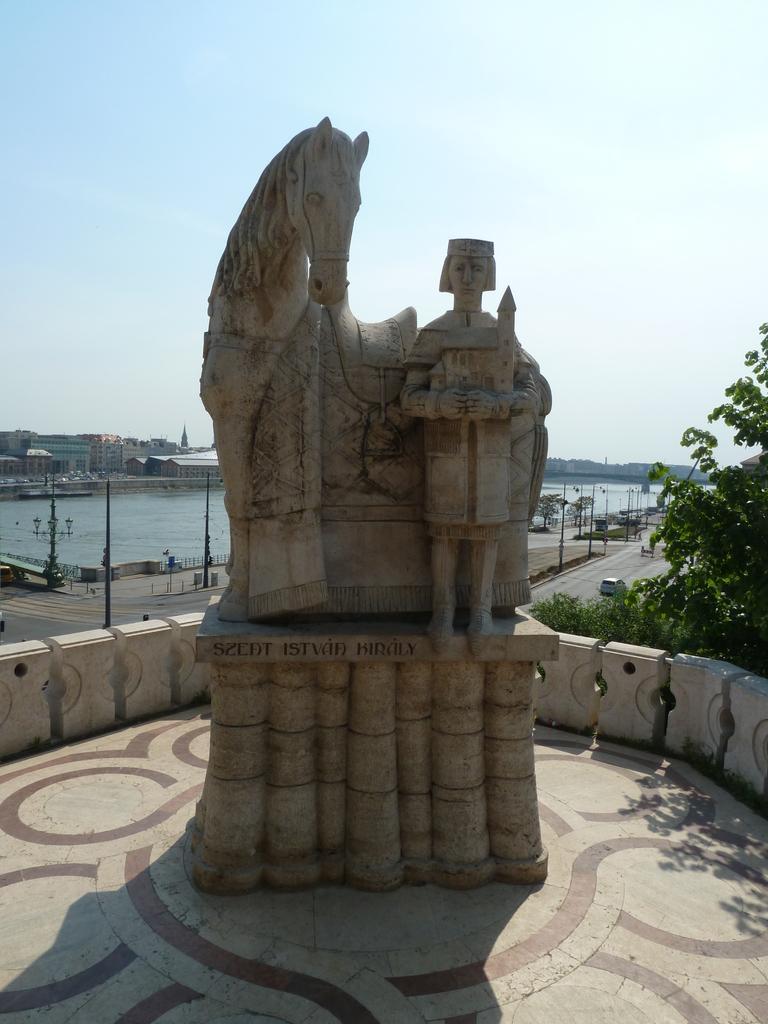Please provide a concise description of this image. There is a sculpture of a horse and a man. There is a tree at the right. There are vehicles, poles on the road. There is water and buildings at the back. 